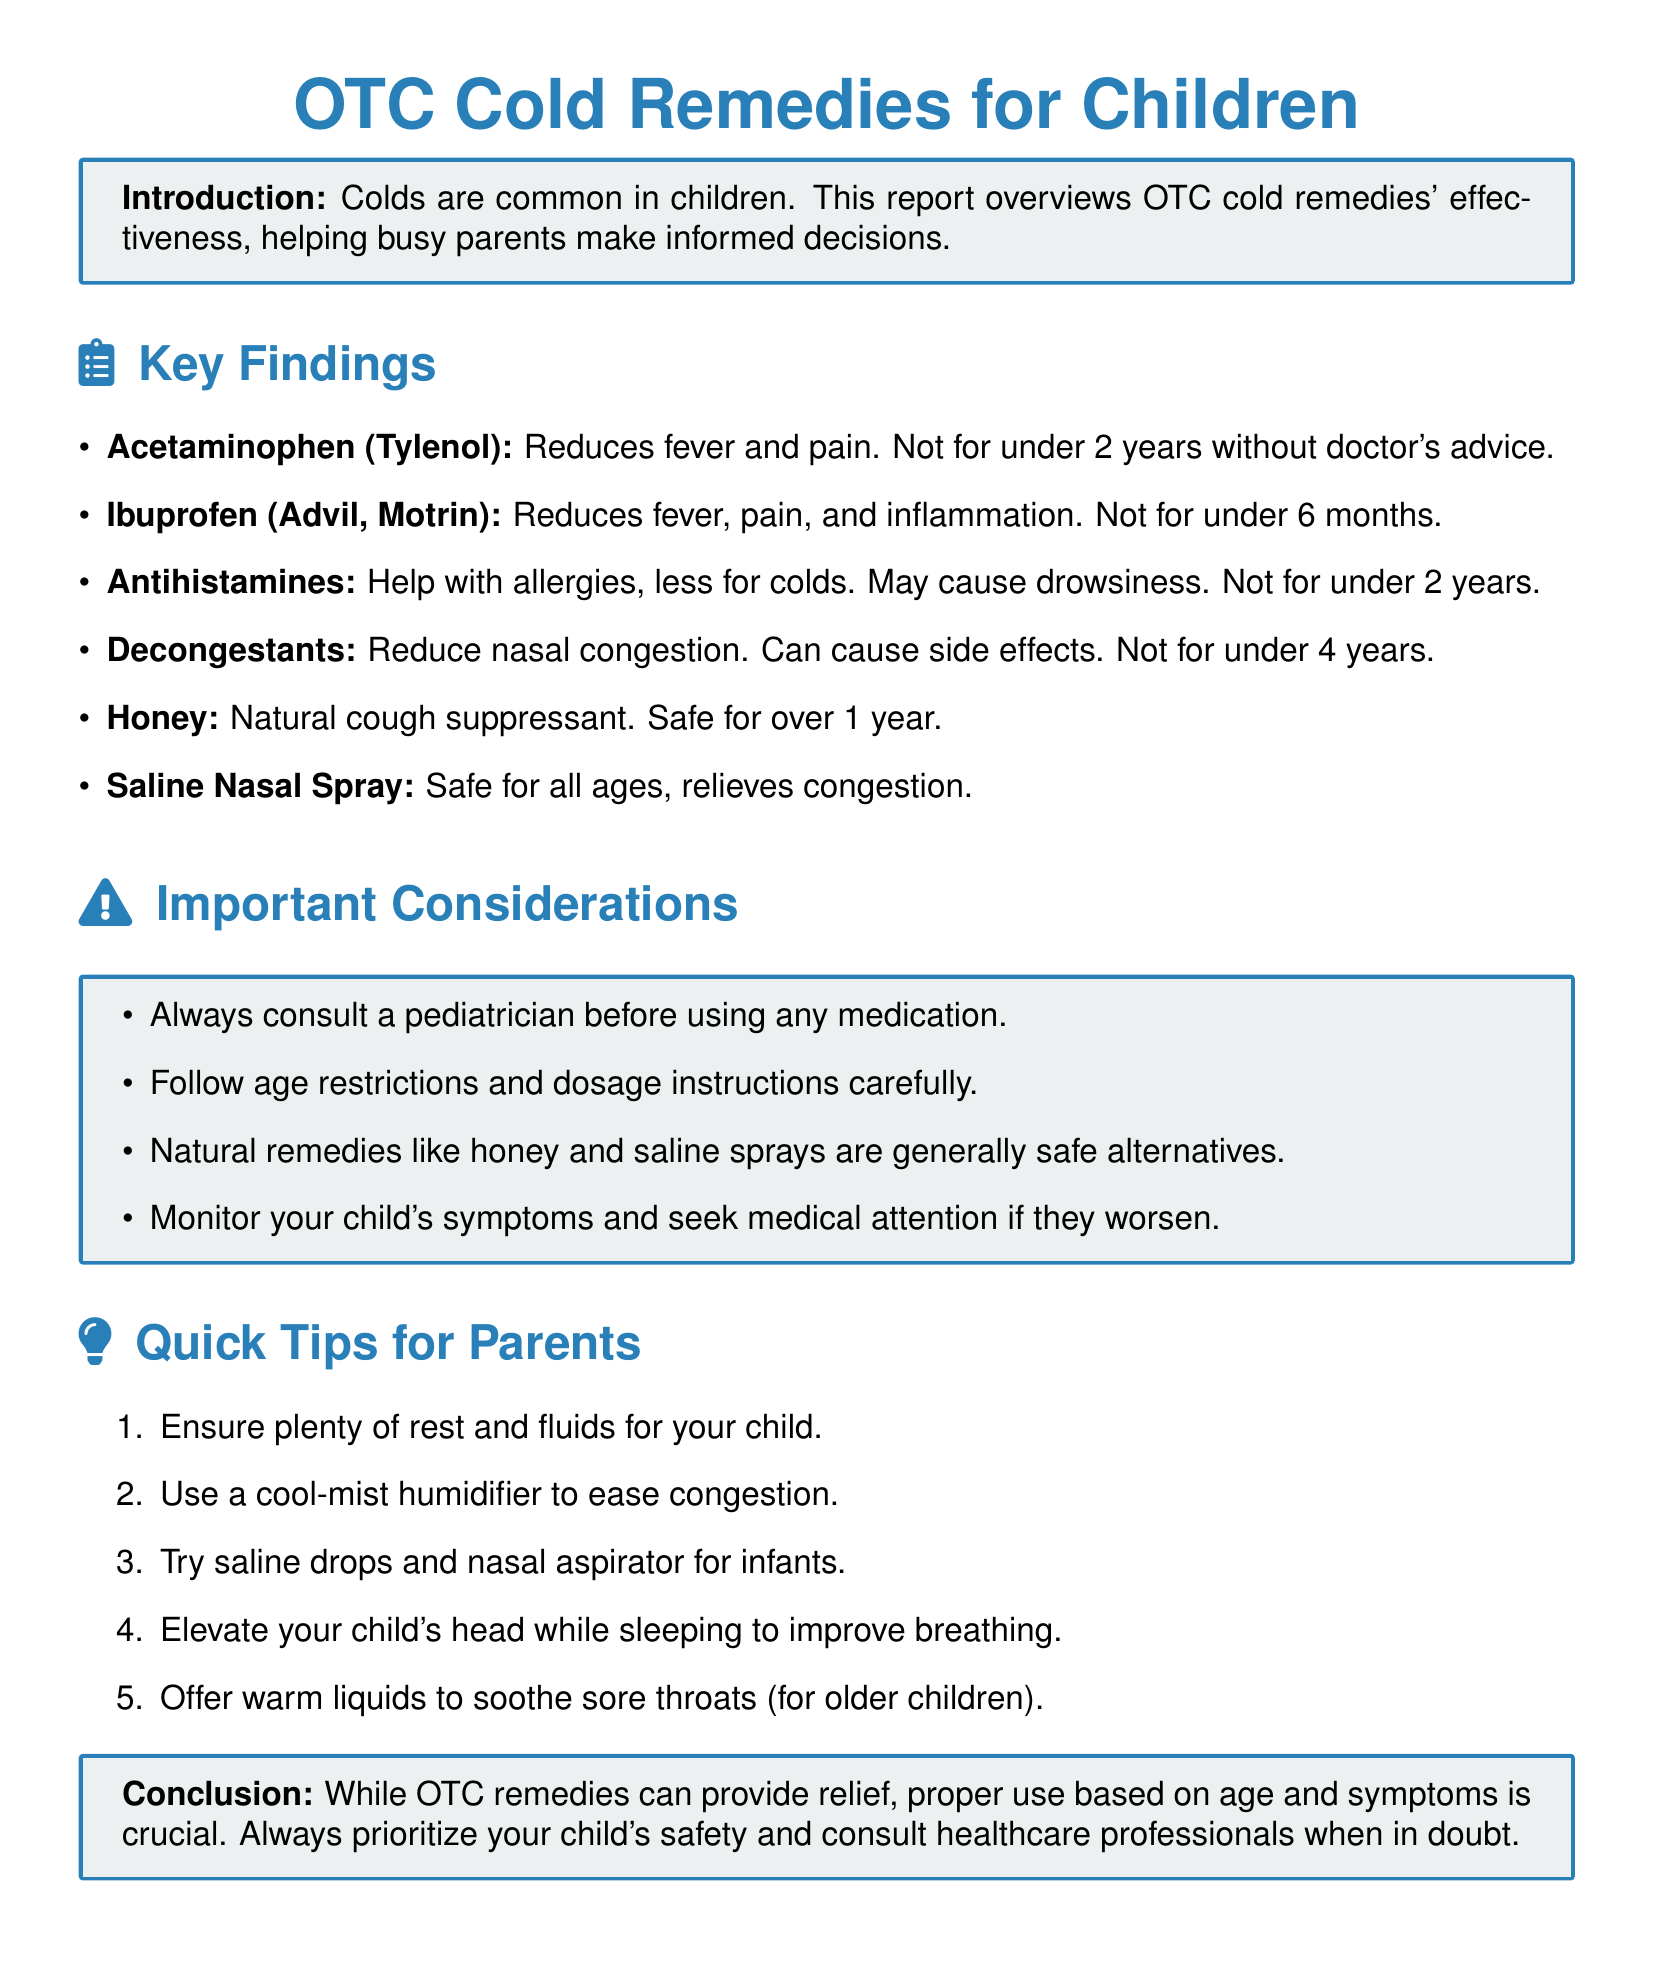What is the main focus of the report? The report focuses on the effectiveness of over-the-counter cold remedies for children.
Answer: Effectiveness of over-the-counter cold remedies for children What age should you avoid giving decongestants? The document states the age restriction for decongestants, which is under 4 years old.
Answer: Under 4 years What natural remedy is safe for children over 1 year? The document mentions honey as a natural remedy safe for older children.
Answer: Honey What should you do before using any medication for your child? The report emphasizes the importance of consulting a pediatrician before medication use.
Answer: Consult a pediatrician Which medication reduces fever and pain? The report identifies acetaminophen (Tylenol) as a medication that reduces fever and pain.
Answer: Acetaminophen (Tylenol) How can a humidifier help a child with a cold? The document suggests using a cool-mist humidifier to ease congestion.
Answer: Eases congestion What is an important consideration when using over-the-counter remedies? Following age restrictions and dosage instructions is highlighted as crucial.
Answer: Follow age restrictions and dosage instructions What is advised for infants to relieve congestion? The report recommends using saline drops and nasal aspirators for infants.
Answer: Saline drops and nasal aspirator 